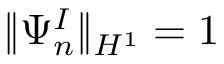Convert formula to latex. <formula><loc_0><loc_0><loc_500><loc_500>\| \Psi _ { n } ^ { I } \| _ { H ^ { 1 } } = 1</formula> 